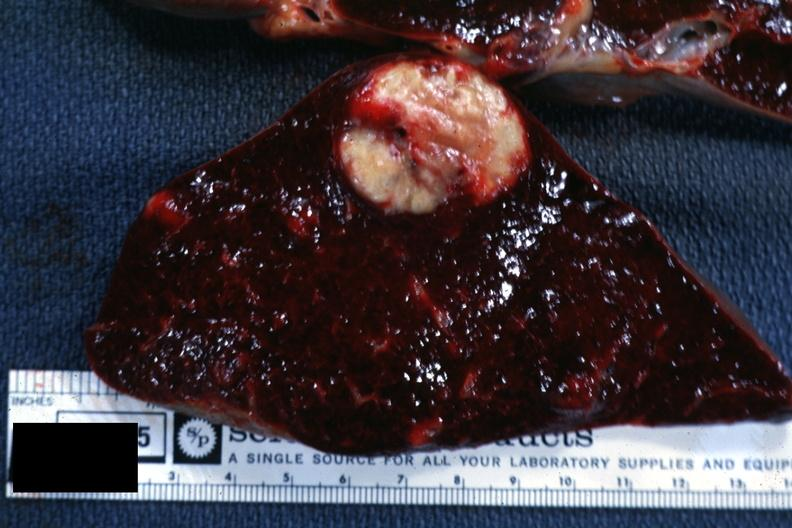what is present?
Answer the question using a single word or phrase. Spleen 